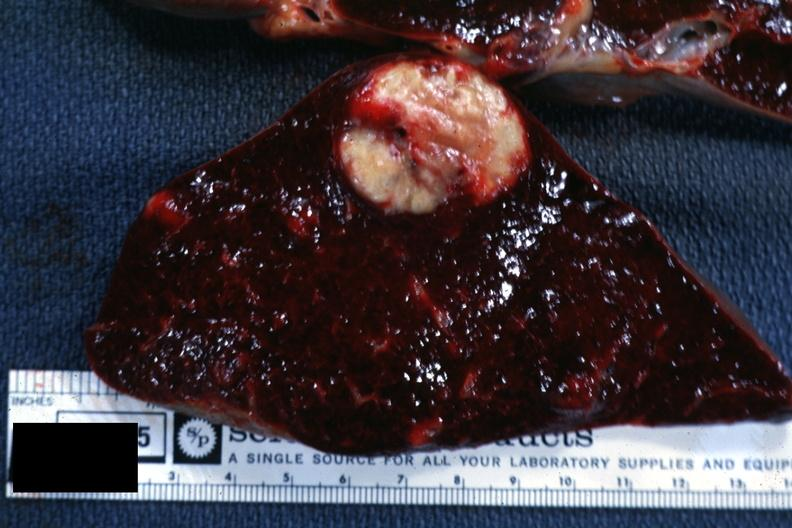what is present?
Answer the question using a single word or phrase. Spleen 